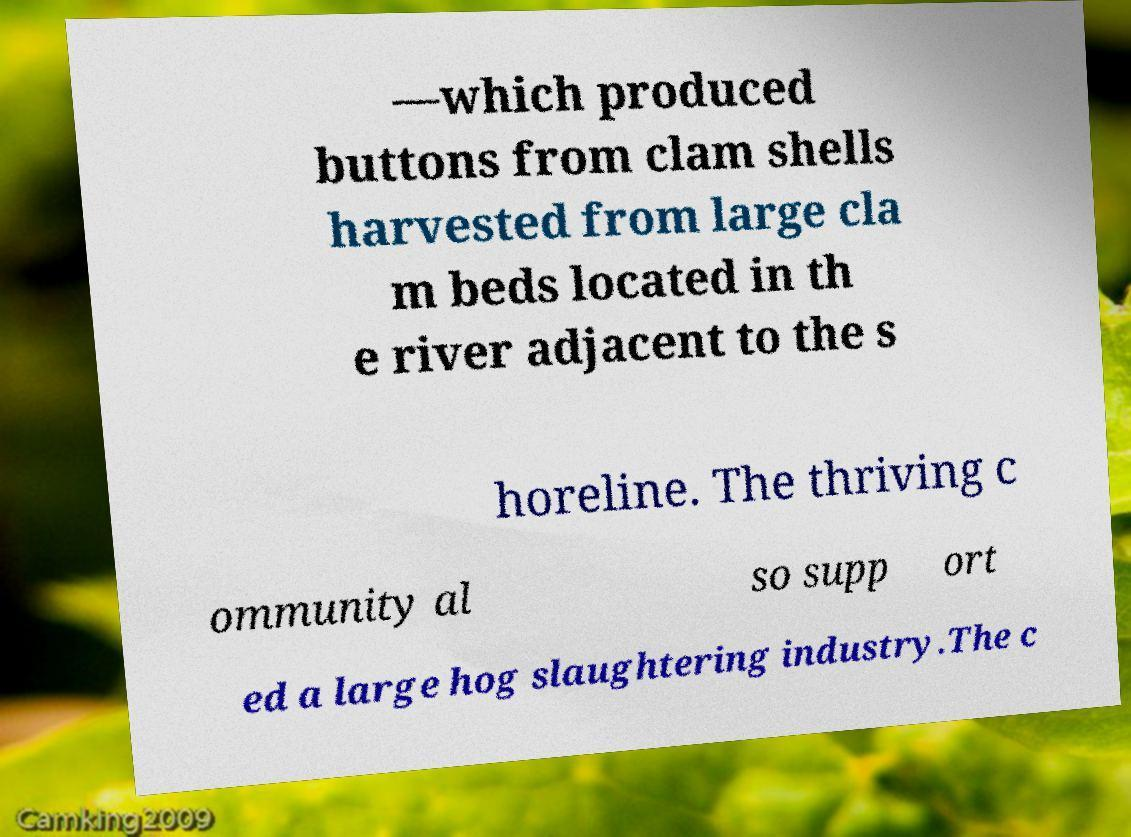Could you assist in decoding the text presented in this image and type it out clearly? —which produced buttons from clam shells harvested from large cla m beds located in th e river adjacent to the s horeline. The thriving c ommunity al so supp ort ed a large hog slaughtering industry.The c 